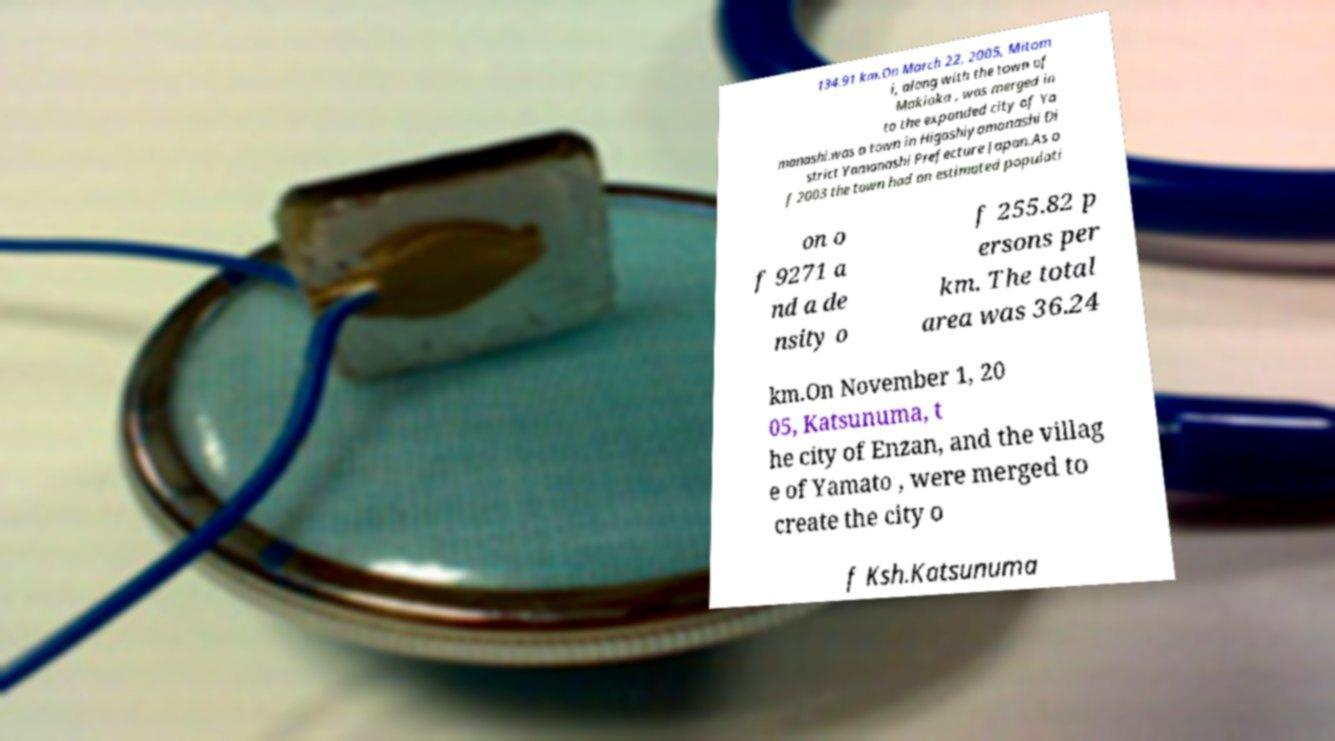Please identify and transcribe the text found in this image. 134.91 km.On March 22, 2005, Mitom i, along with the town of Makioka , was merged in to the expanded city of Ya manashi.was a town in Higashiyamanashi Di strict Yamanashi Prefecture Japan.As o f 2003 the town had an estimated populati on o f 9271 a nd a de nsity o f 255.82 p ersons per km. The total area was 36.24 km.On November 1, 20 05, Katsunuma, t he city of Enzan, and the villag e of Yamato , were merged to create the city o f Ksh.Katsunuma 